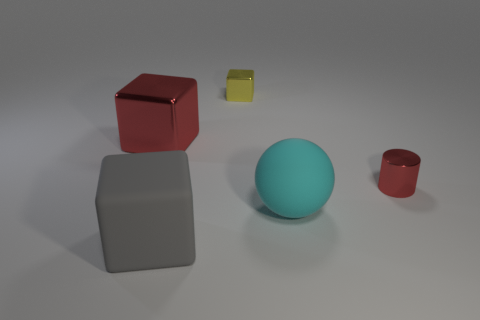Add 3 big blocks. How many objects exist? 8 Subtract all balls. How many objects are left? 4 Add 1 tiny cubes. How many tiny cubes are left? 2 Add 5 small red objects. How many small red objects exist? 6 Subtract 0 gray cylinders. How many objects are left? 5 Subtract all cubes. Subtract all large green spheres. How many objects are left? 2 